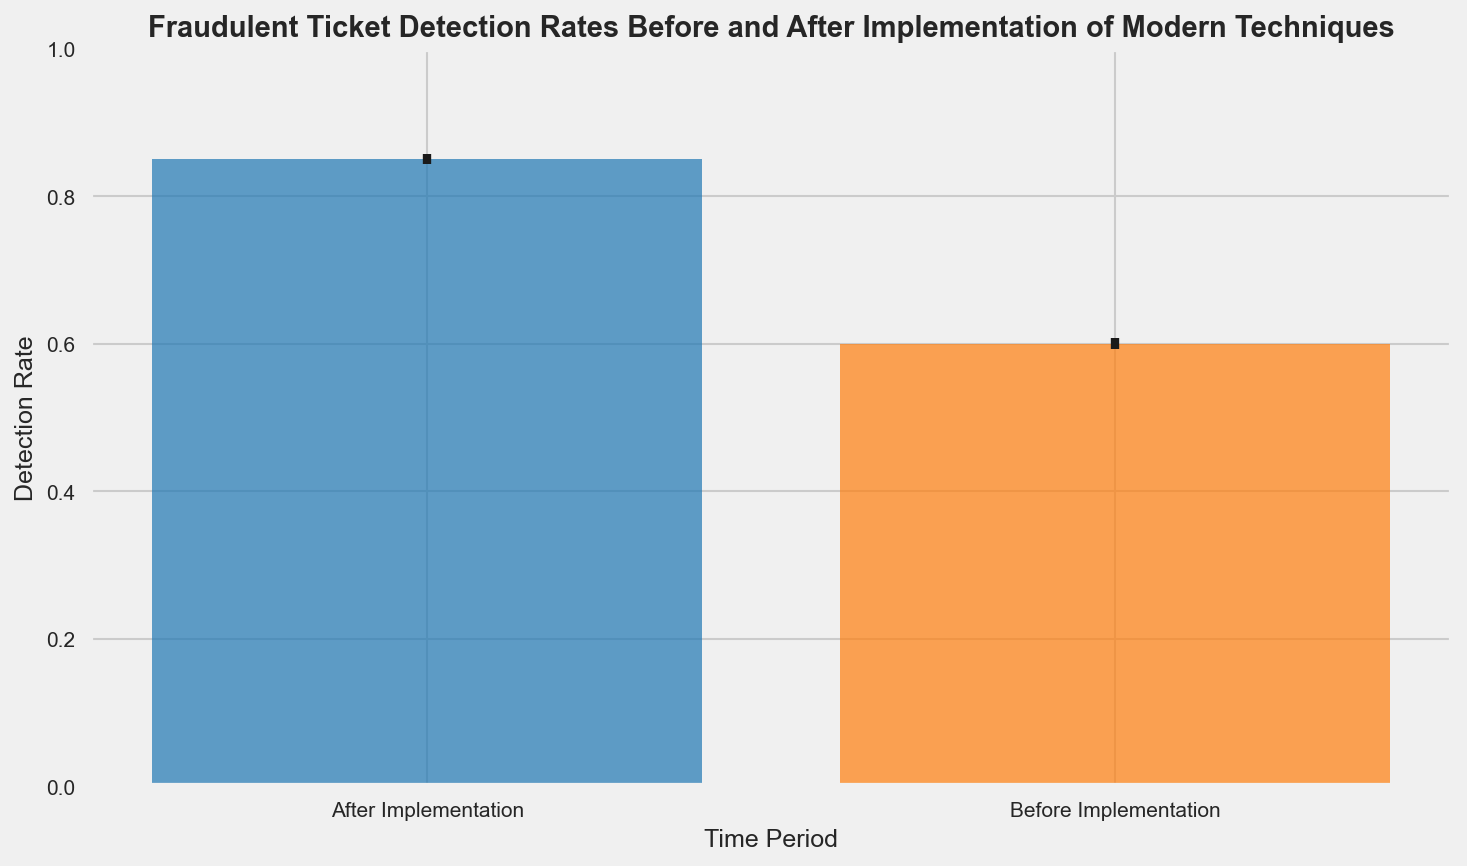What is the detection rate before implementation? To find the detection rate before implementation, look at the height of the bar labeled "Before Implementation". The bar reaches up to approximately 0.60, indicating the average detection rate before modern techniques were implemented.
Answer: 0.60 What is the detection rate after implementation? Look at the height of the bar labeled "After Implementation". The bar reaches up to approximately 0.85, indicating the average detection rate after implementing modern techniques.
Answer: 0.85 Which time period has a higher detection rate? Compare the heights of the two bars. The "After Implementation" bar is taller than the "Before Implementation" bar, indicating a higher detection rate after implementation.
Answer: After Implementation What is the difference in detection rates before and after implementation? Subtract the detection rate before implementation from the after implementation rate, i.e., 0.85 - 0.60. This gives a difference of 0.25.
Answer: 0.25 What range do the error bars cover before implementation? The error bars before implementation extend from the mean detection rate minus the standard error to the mean detection rate plus the standard error (approximately 0.60 - 0.046 and 0.60 + 0.046). This gives a range of approximately 0.55 to 0.65.
Answer: 0.55 to 0.65 What is the ratio of the detection rate after implementation to the detection rate before implementation? Divide the detection rate after implementation by the detection rate before implementation (0.85 / 0.60). The ratio is approximately 1.42.
Answer: 1.42 Is the variation in detection rates higher before implementation or after implementation? Compare the length of the error bars. The error bars for "Before Implementation" are longer, indicating higher variation in detection rates before implementation.
Answer: Before Implementation By how much do the error bars vary within each time period? For "Before Implementation", the error bars vary by approximately 0.05. For "After Implementation", the error bars vary by approximately 0.03. Compare these values to identify the difference in variability.
Answer: Before: 0.05, After: 0.03 